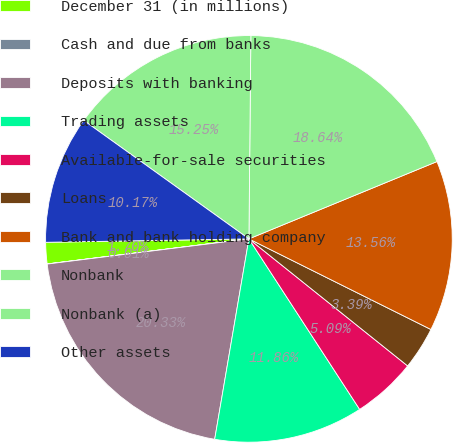Convert chart. <chart><loc_0><loc_0><loc_500><loc_500><pie_chart><fcel>December 31 (in millions)<fcel>Cash and due from banks<fcel>Deposits with banking<fcel>Trading assets<fcel>Available-for-sale securities<fcel>Loans<fcel>Bank and bank holding company<fcel>Nonbank<fcel>Nonbank (a)<fcel>Other assets<nl><fcel>1.7%<fcel>0.01%<fcel>20.33%<fcel>11.86%<fcel>5.09%<fcel>3.39%<fcel>13.56%<fcel>18.64%<fcel>15.25%<fcel>10.17%<nl></chart> 